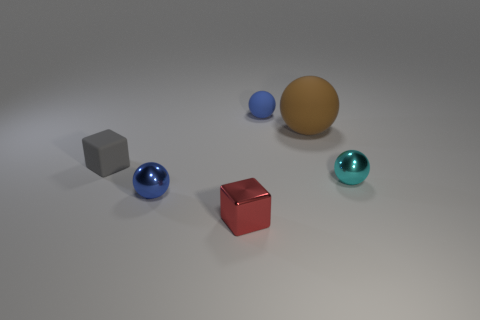Subtract all large brown matte spheres. How many spheres are left? 3 Subtract all cyan balls. How many balls are left? 3 Add 1 gray cubes. How many objects exist? 7 Subtract 2 spheres. How many spheres are left? 2 Subtract all blue blocks. How many blue balls are left? 2 Subtract all blocks. How many objects are left? 4 Subtract all big cyan objects. Subtract all small blue matte spheres. How many objects are left? 5 Add 6 brown balls. How many brown balls are left? 7 Add 1 large cyan metal spheres. How many large cyan metal spheres exist? 1 Subtract 0 brown cylinders. How many objects are left? 6 